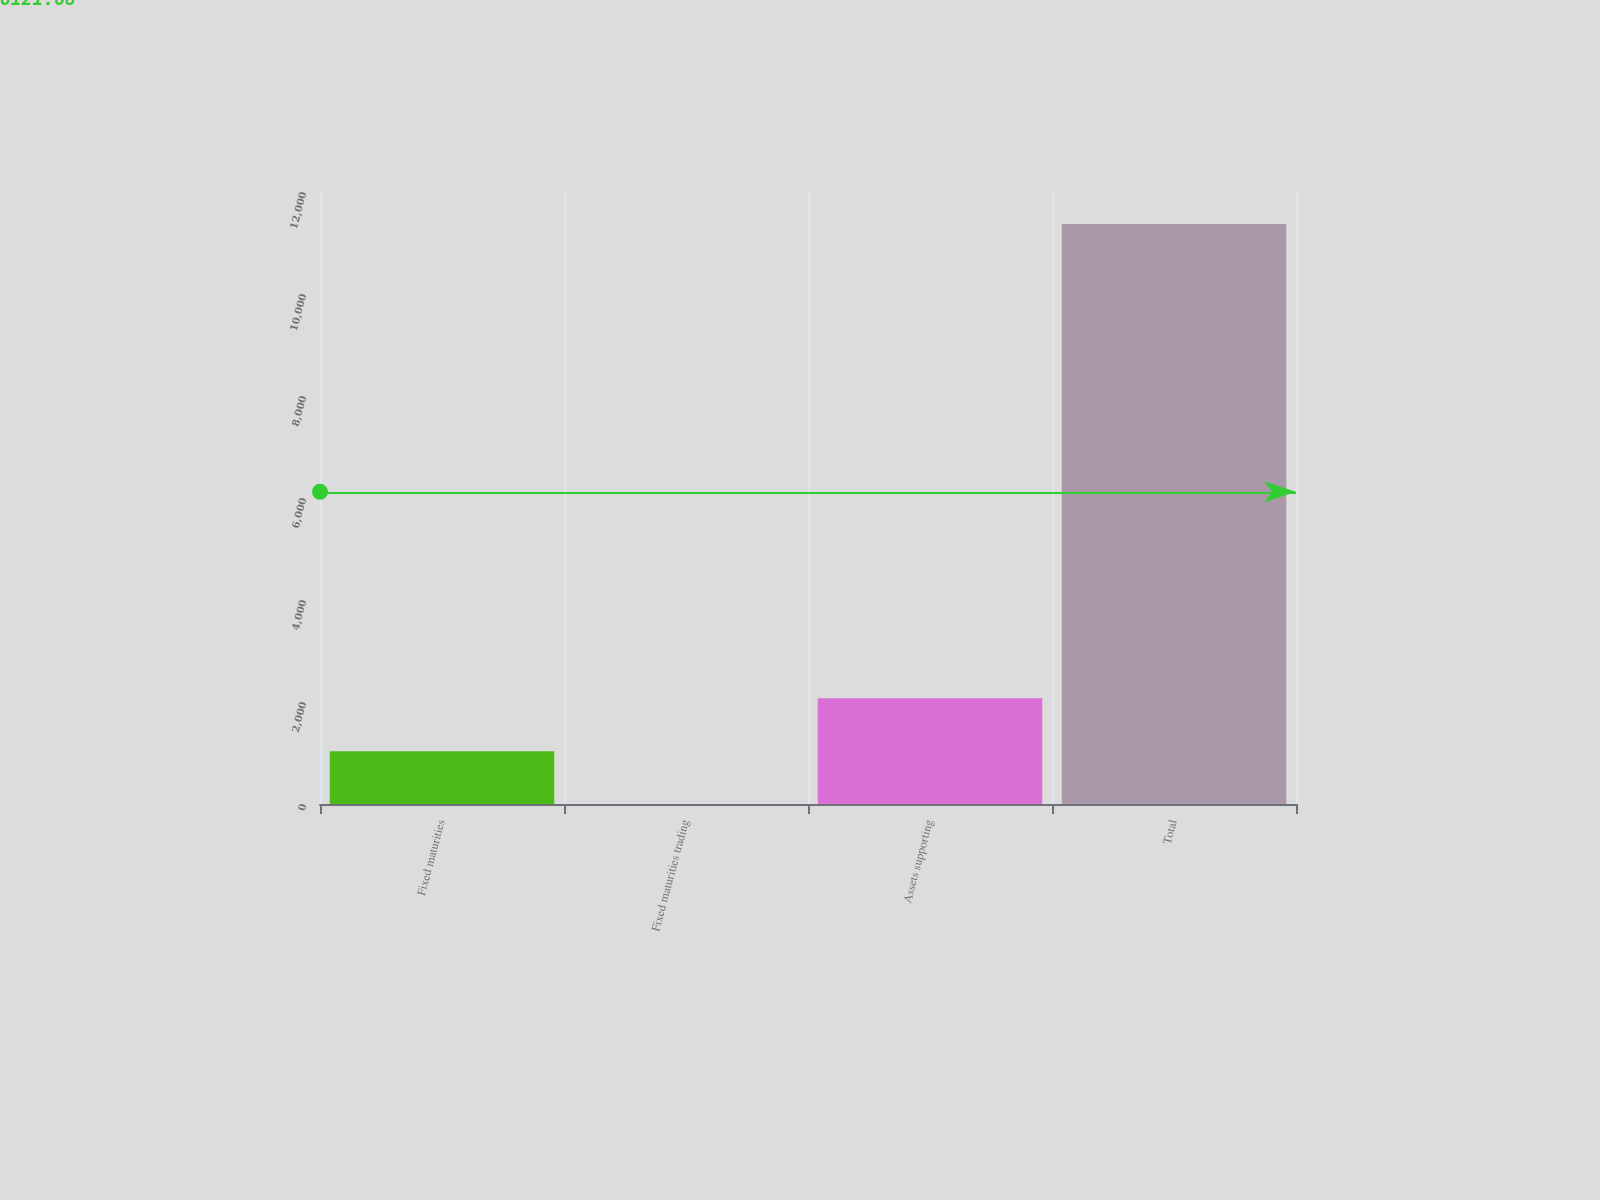Convert chart to OTSL. <chart><loc_0><loc_0><loc_500><loc_500><bar_chart><fcel>Fixed maturities<fcel>Fixed maturities trading<fcel>Assets supporting<fcel>Total<nl><fcel>1035.82<fcel>0.47<fcel>2071.17<fcel>11374.4<nl></chart> 